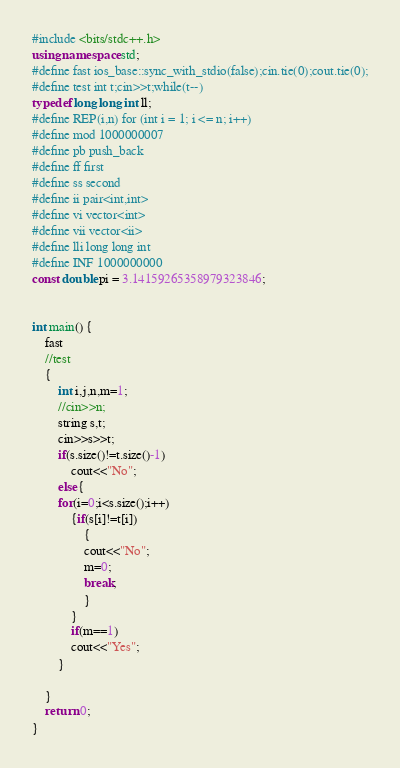Convert code to text. <code><loc_0><loc_0><loc_500><loc_500><_C++_>#include <bits/stdc++.h>
using namespace std;
#define fast ios_base::sync_with_stdio(false);cin.tie(0);cout.tie(0);
#define test int t;cin>>t;while(t--)
typedef long long int ll;
#define REP(i,n) for (int i = 1; i <= n; i++)
#define mod 1000000007
#define pb push_back
#define ff first
#define ss second
#define ii pair<int,int>
#define vi vector<int>
#define vii vector<ii>
#define lli long long int
#define INF 1000000000
const double pi = 3.14159265358979323846;


int main() {
    fast
    //test
    {
        int i,j,n,m=1;
        //cin>>n;
		string s,t;
      	cin>>s>>t;
        if(s.size()!=t.size()-1)
            cout<<"No";
        else{
        for(i=0;i<s.size();i++)
            {if(s[i]!=t[i])
                {
                cout<<"No";
                m=0;
                break;
                }
            }
            if(m==1)
            cout<<"Yes";
        }
		      
    }
    return 0;
}
</code> 